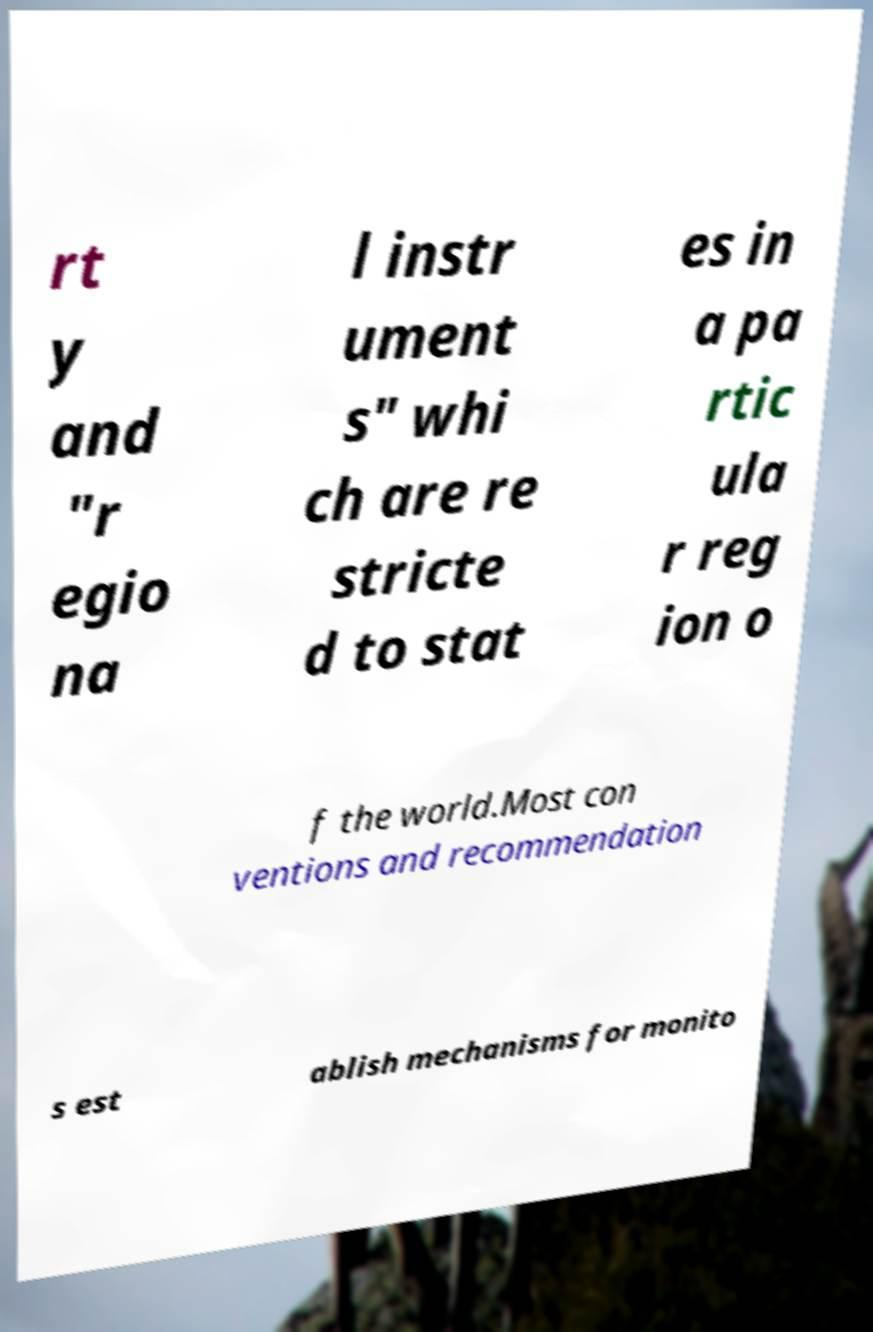I need the written content from this picture converted into text. Can you do that? rt y and "r egio na l instr ument s" whi ch are re stricte d to stat es in a pa rtic ula r reg ion o f the world.Most con ventions and recommendation s est ablish mechanisms for monito 